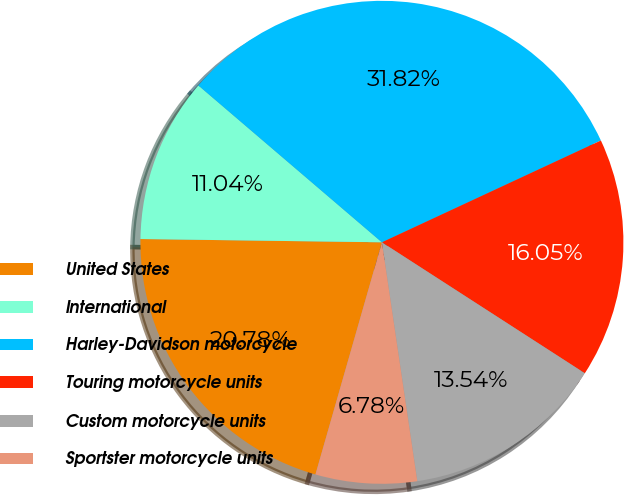Convert chart. <chart><loc_0><loc_0><loc_500><loc_500><pie_chart><fcel>United States<fcel>International<fcel>Harley-Davidson motorcycle<fcel>Touring motorcycle units<fcel>Custom motorcycle units<fcel>Sportster motorcycle units<nl><fcel>20.78%<fcel>11.04%<fcel>31.82%<fcel>16.05%<fcel>13.54%<fcel>6.78%<nl></chart> 